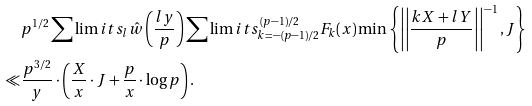<formula> <loc_0><loc_0><loc_500><loc_500>& p ^ { 1 / 2 } \sum \lim i t s _ { l } \hat { w } \left ( \frac { l y } { p } \right ) \sum \lim i t s _ { k = - ( p - 1 ) / 2 } ^ { ( p - 1 ) / 2 } F _ { k } ( x ) \min \left \{ \left | \left | \frac { k X + l Y } { p } \right | \right | ^ { - 1 } , J \right \} \\ \ll & \frac { p ^ { 3 / 2 } } { y } \cdot \left ( \frac { X } { x } \cdot J + \frac { p } { x } \cdot \log p \right ) .</formula> 